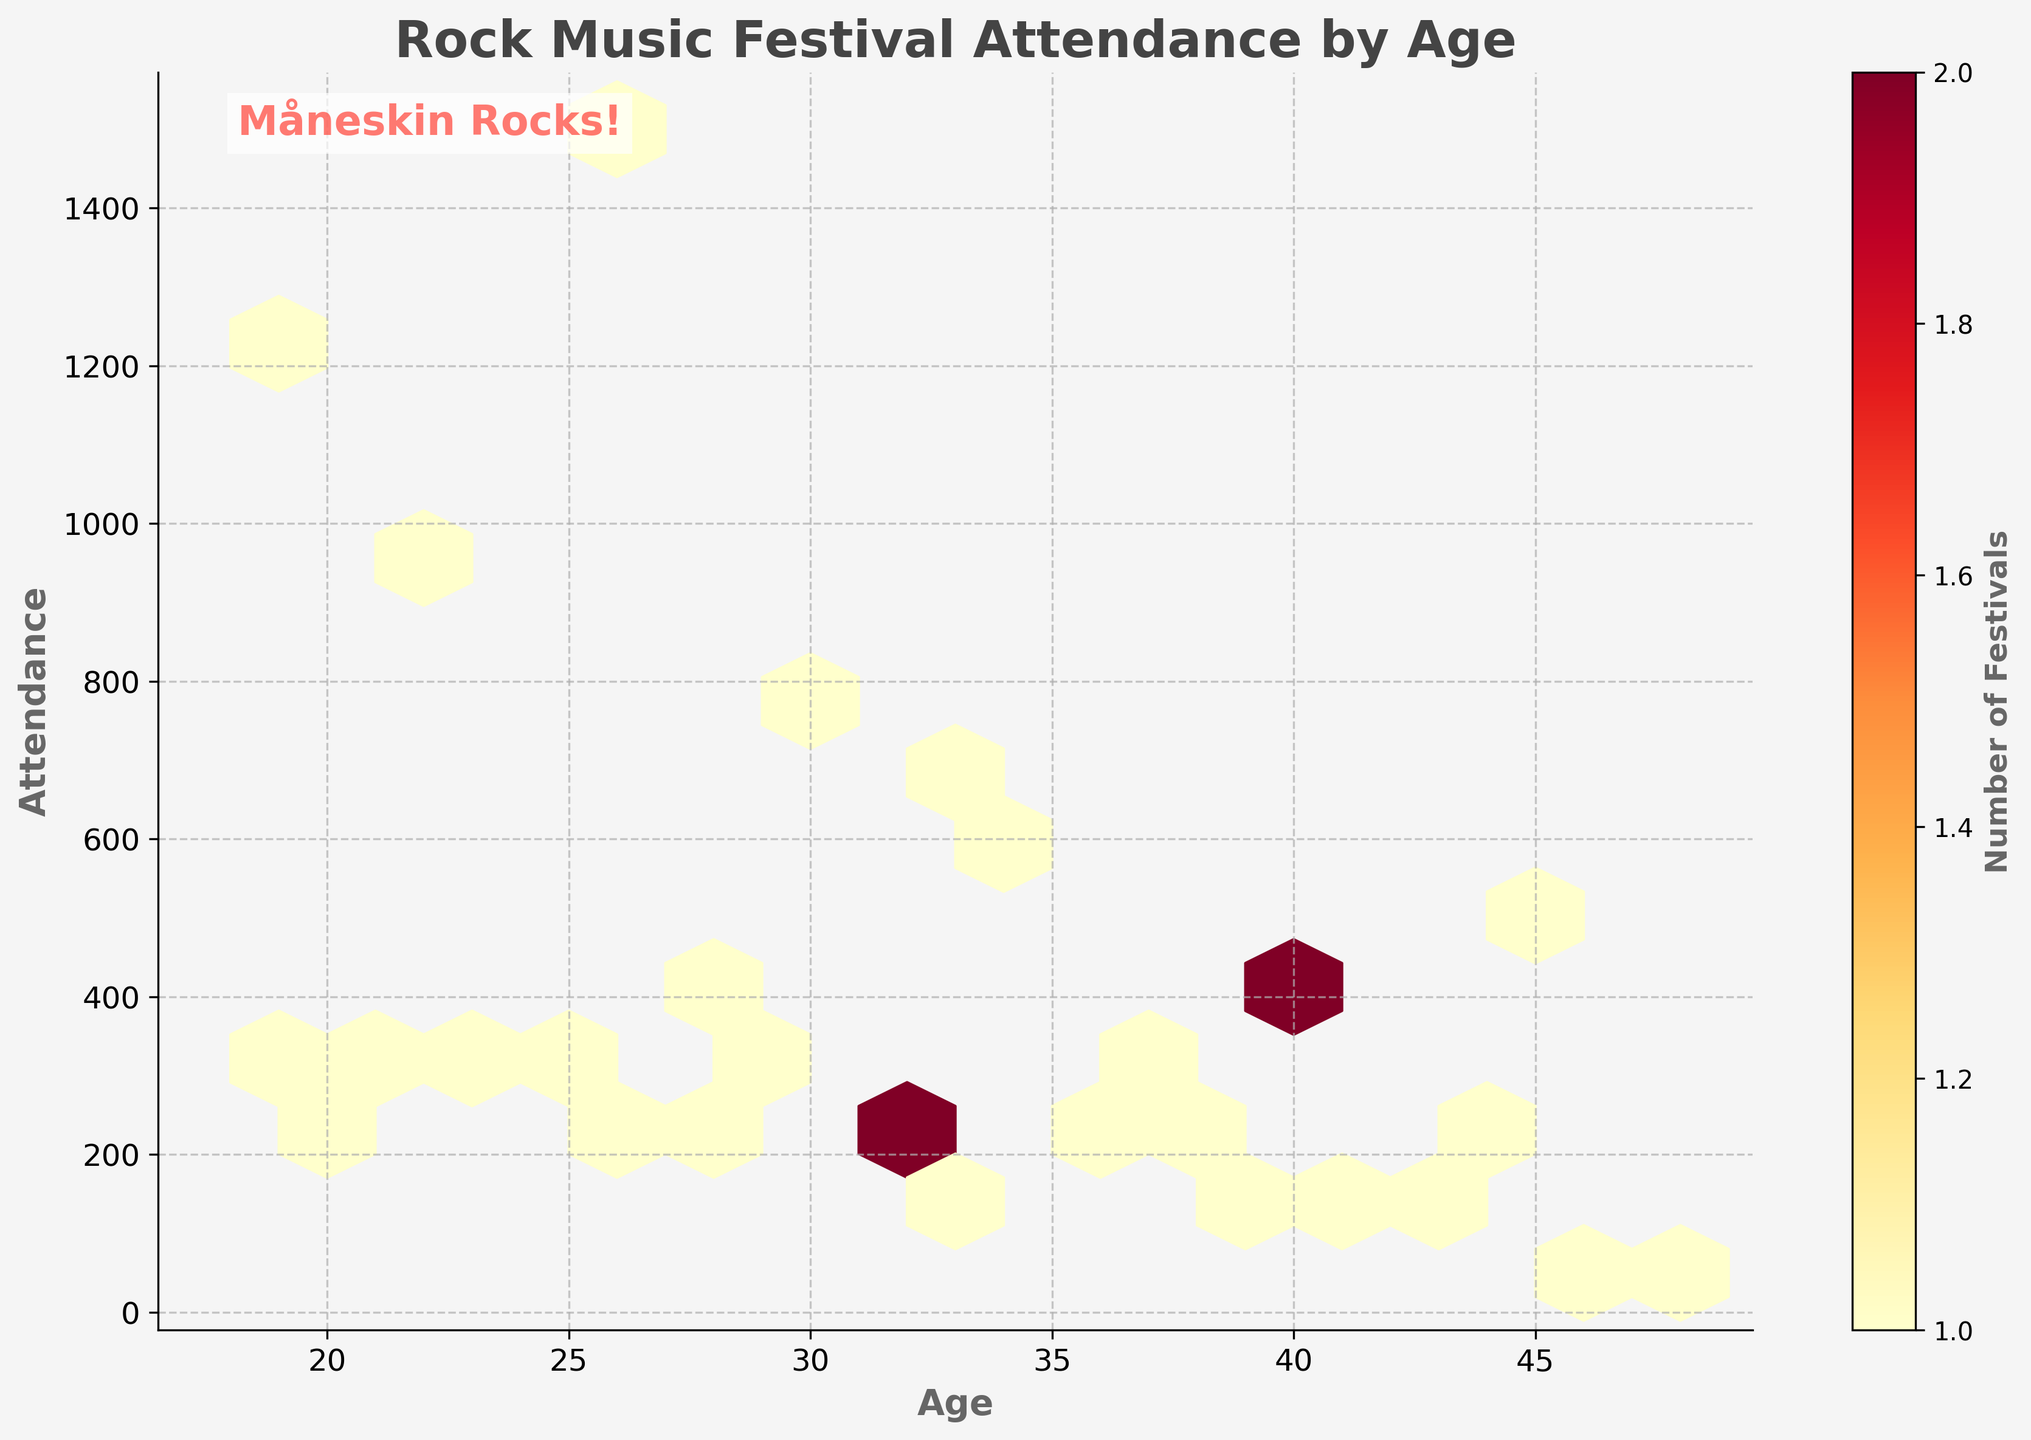What is the title of the hexbin plot? The title is usually located at the top of the plot and is written in larger, bold font. It provides a brief description of what the plot represents. In this case, the title reads "Rock Music Festival Attendance by Age."
Answer: Rock Music Festival Attendance by Age What are the x and y axes labels? The labels for the x and y axes are typically found beside each axis. They provide context for the data being plotted. In this figure, the x-axis represents "Age" and the y-axis represents "Attendance."
Answer: Age and Attendance What does the colorbar represent in the plot? The colorbar is usually placed beside the hexbin plot and provides information about the color scale used in the plot. It indicates the 'Number of Festivals,' showing how many festivals correspond to each hexbin's color.
Answer: Number of Festivals Which age group has the highest attendance density? To determine the highest attendance density, look for the darkest hexagons in the plot since they indicate higher densities. The age group around 25 has the darkest hexagons, signifying the highest attendance density.
Answer: Around 25 What age group generally shows the lowest attendance density? Look for the lightest or less colored hexagons. The higher ages (e.g., 45-48) and some lower ages (e.g., 18-19) show lighter hexagons, indicating lower attendance densities.
Answer: 45-48 and 18-19 Is there a specific age range where the attendance density peaks? By examining the plot, we notice that the darkest hexagons, which represent the highest densities, are concentrated around the age range of 20-30. This indicates a peak in attendance density within this age range.
Answer: 20-30 How does the attendance of the age group 18 compare to age group 30? Comparing the densities for age groups 18 and 30, age group 18 shows fewer and lighter hexagons, indicating lower attendance, while age group 30 has more and darker hexagons, indicating higher attendance.
Answer: Lower for age 18 than age 30 What does the text "Måneskin Rocks!" signify in the plot? The text "Måneskin Rocks!" is a stylistic addition to the plot, likely indicating the creator's appreciation for the band Måneskin. It doesn't convey any data-related information.
Answer: It's a stylistic addition 